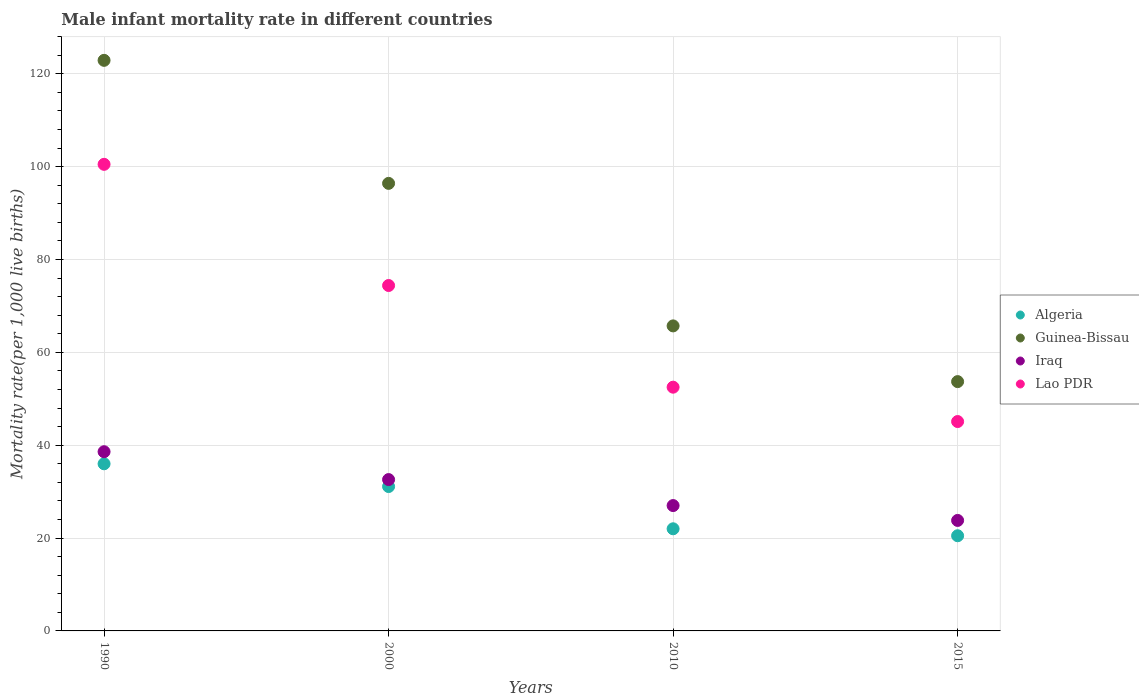Is the number of dotlines equal to the number of legend labels?
Your answer should be very brief. Yes. What is the male infant mortality rate in Guinea-Bissau in 2010?
Your answer should be compact. 65.7. Across all years, what is the maximum male infant mortality rate in Lao PDR?
Offer a very short reply. 100.5. Across all years, what is the minimum male infant mortality rate in Iraq?
Your answer should be very brief. 23.8. In which year was the male infant mortality rate in Algeria maximum?
Your response must be concise. 1990. In which year was the male infant mortality rate in Algeria minimum?
Give a very brief answer. 2015. What is the total male infant mortality rate in Lao PDR in the graph?
Provide a succinct answer. 272.5. What is the difference between the male infant mortality rate in Iraq in 1990 and that in 2010?
Your answer should be very brief. 11.6. What is the difference between the male infant mortality rate in Algeria in 2015 and the male infant mortality rate in Iraq in 1990?
Make the answer very short. -18.1. What is the average male infant mortality rate in Algeria per year?
Offer a terse response. 27.4. In the year 1990, what is the difference between the male infant mortality rate in Algeria and male infant mortality rate in Iraq?
Your answer should be very brief. -2.6. What is the ratio of the male infant mortality rate in Guinea-Bissau in 1990 to that in 2010?
Give a very brief answer. 1.87. Is the male infant mortality rate in Iraq in 1990 less than that in 2015?
Keep it short and to the point. No. What is the difference between the highest and the second highest male infant mortality rate in Lao PDR?
Provide a short and direct response. 26.1. In how many years, is the male infant mortality rate in Guinea-Bissau greater than the average male infant mortality rate in Guinea-Bissau taken over all years?
Offer a very short reply. 2. Is it the case that in every year, the sum of the male infant mortality rate in Guinea-Bissau and male infant mortality rate in Lao PDR  is greater than the sum of male infant mortality rate in Algeria and male infant mortality rate in Iraq?
Give a very brief answer. Yes. Does the male infant mortality rate in Guinea-Bissau monotonically increase over the years?
Keep it short and to the point. No. How many dotlines are there?
Offer a very short reply. 4. Are the values on the major ticks of Y-axis written in scientific E-notation?
Your answer should be very brief. No. Does the graph contain any zero values?
Your response must be concise. No. How many legend labels are there?
Ensure brevity in your answer.  4. How are the legend labels stacked?
Your answer should be very brief. Vertical. What is the title of the graph?
Your answer should be compact. Male infant mortality rate in different countries. What is the label or title of the X-axis?
Provide a short and direct response. Years. What is the label or title of the Y-axis?
Make the answer very short. Mortality rate(per 1,0 live births). What is the Mortality rate(per 1,000 live births) in Guinea-Bissau in 1990?
Offer a very short reply. 122.9. What is the Mortality rate(per 1,000 live births) in Iraq in 1990?
Your answer should be compact. 38.6. What is the Mortality rate(per 1,000 live births) in Lao PDR in 1990?
Your answer should be very brief. 100.5. What is the Mortality rate(per 1,000 live births) in Algeria in 2000?
Your response must be concise. 31.1. What is the Mortality rate(per 1,000 live births) in Guinea-Bissau in 2000?
Ensure brevity in your answer.  96.4. What is the Mortality rate(per 1,000 live births) of Iraq in 2000?
Provide a short and direct response. 32.6. What is the Mortality rate(per 1,000 live births) in Lao PDR in 2000?
Provide a short and direct response. 74.4. What is the Mortality rate(per 1,000 live births) of Guinea-Bissau in 2010?
Your answer should be very brief. 65.7. What is the Mortality rate(per 1,000 live births) in Lao PDR in 2010?
Offer a terse response. 52.5. What is the Mortality rate(per 1,000 live births) in Algeria in 2015?
Provide a short and direct response. 20.5. What is the Mortality rate(per 1,000 live births) in Guinea-Bissau in 2015?
Your answer should be compact. 53.7. What is the Mortality rate(per 1,000 live births) in Iraq in 2015?
Ensure brevity in your answer.  23.8. What is the Mortality rate(per 1,000 live births) in Lao PDR in 2015?
Provide a succinct answer. 45.1. Across all years, what is the maximum Mortality rate(per 1,000 live births) in Algeria?
Your answer should be compact. 36. Across all years, what is the maximum Mortality rate(per 1,000 live births) in Guinea-Bissau?
Keep it short and to the point. 122.9. Across all years, what is the maximum Mortality rate(per 1,000 live births) in Iraq?
Provide a short and direct response. 38.6. Across all years, what is the maximum Mortality rate(per 1,000 live births) in Lao PDR?
Your response must be concise. 100.5. Across all years, what is the minimum Mortality rate(per 1,000 live births) in Guinea-Bissau?
Offer a terse response. 53.7. Across all years, what is the minimum Mortality rate(per 1,000 live births) of Iraq?
Your answer should be very brief. 23.8. Across all years, what is the minimum Mortality rate(per 1,000 live births) of Lao PDR?
Ensure brevity in your answer.  45.1. What is the total Mortality rate(per 1,000 live births) of Algeria in the graph?
Your response must be concise. 109.6. What is the total Mortality rate(per 1,000 live births) of Guinea-Bissau in the graph?
Your response must be concise. 338.7. What is the total Mortality rate(per 1,000 live births) in Iraq in the graph?
Your response must be concise. 122. What is the total Mortality rate(per 1,000 live births) in Lao PDR in the graph?
Make the answer very short. 272.5. What is the difference between the Mortality rate(per 1,000 live births) in Algeria in 1990 and that in 2000?
Your response must be concise. 4.9. What is the difference between the Mortality rate(per 1,000 live births) of Iraq in 1990 and that in 2000?
Offer a terse response. 6. What is the difference between the Mortality rate(per 1,000 live births) of Lao PDR in 1990 and that in 2000?
Provide a succinct answer. 26.1. What is the difference between the Mortality rate(per 1,000 live births) in Guinea-Bissau in 1990 and that in 2010?
Keep it short and to the point. 57.2. What is the difference between the Mortality rate(per 1,000 live births) of Iraq in 1990 and that in 2010?
Keep it short and to the point. 11.6. What is the difference between the Mortality rate(per 1,000 live births) in Algeria in 1990 and that in 2015?
Provide a short and direct response. 15.5. What is the difference between the Mortality rate(per 1,000 live births) of Guinea-Bissau in 1990 and that in 2015?
Offer a very short reply. 69.2. What is the difference between the Mortality rate(per 1,000 live births) of Iraq in 1990 and that in 2015?
Keep it short and to the point. 14.8. What is the difference between the Mortality rate(per 1,000 live births) of Lao PDR in 1990 and that in 2015?
Offer a very short reply. 55.4. What is the difference between the Mortality rate(per 1,000 live births) of Algeria in 2000 and that in 2010?
Keep it short and to the point. 9.1. What is the difference between the Mortality rate(per 1,000 live births) in Guinea-Bissau in 2000 and that in 2010?
Your response must be concise. 30.7. What is the difference between the Mortality rate(per 1,000 live births) of Lao PDR in 2000 and that in 2010?
Provide a succinct answer. 21.9. What is the difference between the Mortality rate(per 1,000 live births) in Guinea-Bissau in 2000 and that in 2015?
Offer a very short reply. 42.7. What is the difference between the Mortality rate(per 1,000 live births) of Lao PDR in 2000 and that in 2015?
Your answer should be compact. 29.3. What is the difference between the Mortality rate(per 1,000 live births) of Iraq in 2010 and that in 2015?
Your answer should be very brief. 3.2. What is the difference between the Mortality rate(per 1,000 live births) of Algeria in 1990 and the Mortality rate(per 1,000 live births) of Guinea-Bissau in 2000?
Offer a very short reply. -60.4. What is the difference between the Mortality rate(per 1,000 live births) in Algeria in 1990 and the Mortality rate(per 1,000 live births) in Lao PDR in 2000?
Make the answer very short. -38.4. What is the difference between the Mortality rate(per 1,000 live births) of Guinea-Bissau in 1990 and the Mortality rate(per 1,000 live births) of Iraq in 2000?
Offer a terse response. 90.3. What is the difference between the Mortality rate(per 1,000 live births) in Guinea-Bissau in 1990 and the Mortality rate(per 1,000 live births) in Lao PDR in 2000?
Ensure brevity in your answer.  48.5. What is the difference between the Mortality rate(per 1,000 live births) of Iraq in 1990 and the Mortality rate(per 1,000 live births) of Lao PDR in 2000?
Provide a succinct answer. -35.8. What is the difference between the Mortality rate(per 1,000 live births) of Algeria in 1990 and the Mortality rate(per 1,000 live births) of Guinea-Bissau in 2010?
Your response must be concise. -29.7. What is the difference between the Mortality rate(per 1,000 live births) of Algeria in 1990 and the Mortality rate(per 1,000 live births) of Lao PDR in 2010?
Make the answer very short. -16.5. What is the difference between the Mortality rate(per 1,000 live births) of Guinea-Bissau in 1990 and the Mortality rate(per 1,000 live births) of Iraq in 2010?
Ensure brevity in your answer.  95.9. What is the difference between the Mortality rate(per 1,000 live births) of Guinea-Bissau in 1990 and the Mortality rate(per 1,000 live births) of Lao PDR in 2010?
Make the answer very short. 70.4. What is the difference between the Mortality rate(per 1,000 live births) of Iraq in 1990 and the Mortality rate(per 1,000 live births) of Lao PDR in 2010?
Ensure brevity in your answer.  -13.9. What is the difference between the Mortality rate(per 1,000 live births) in Algeria in 1990 and the Mortality rate(per 1,000 live births) in Guinea-Bissau in 2015?
Your response must be concise. -17.7. What is the difference between the Mortality rate(per 1,000 live births) in Algeria in 1990 and the Mortality rate(per 1,000 live births) in Iraq in 2015?
Provide a short and direct response. 12.2. What is the difference between the Mortality rate(per 1,000 live births) in Guinea-Bissau in 1990 and the Mortality rate(per 1,000 live births) in Iraq in 2015?
Keep it short and to the point. 99.1. What is the difference between the Mortality rate(per 1,000 live births) of Guinea-Bissau in 1990 and the Mortality rate(per 1,000 live births) of Lao PDR in 2015?
Give a very brief answer. 77.8. What is the difference between the Mortality rate(per 1,000 live births) of Algeria in 2000 and the Mortality rate(per 1,000 live births) of Guinea-Bissau in 2010?
Ensure brevity in your answer.  -34.6. What is the difference between the Mortality rate(per 1,000 live births) of Algeria in 2000 and the Mortality rate(per 1,000 live births) of Iraq in 2010?
Offer a terse response. 4.1. What is the difference between the Mortality rate(per 1,000 live births) of Algeria in 2000 and the Mortality rate(per 1,000 live births) of Lao PDR in 2010?
Give a very brief answer. -21.4. What is the difference between the Mortality rate(per 1,000 live births) of Guinea-Bissau in 2000 and the Mortality rate(per 1,000 live births) of Iraq in 2010?
Your response must be concise. 69.4. What is the difference between the Mortality rate(per 1,000 live births) in Guinea-Bissau in 2000 and the Mortality rate(per 1,000 live births) in Lao PDR in 2010?
Provide a short and direct response. 43.9. What is the difference between the Mortality rate(per 1,000 live births) of Iraq in 2000 and the Mortality rate(per 1,000 live births) of Lao PDR in 2010?
Your answer should be very brief. -19.9. What is the difference between the Mortality rate(per 1,000 live births) of Algeria in 2000 and the Mortality rate(per 1,000 live births) of Guinea-Bissau in 2015?
Your response must be concise. -22.6. What is the difference between the Mortality rate(per 1,000 live births) in Algeria in 2000 and the Mortality rate(per 1,000 live births) in Iraq in 2015?
Offer a very short reply. 7.3. What is the difference between the Mortality rate(per 1,000 live births) in Guinea-Bissau in 2000 and the Mortality rate(per 1,000 live births) in Iraq in 2015?
Ensure brevity in your answer.  72.6. What is the difference between the Mortality rate(per 1,000 live births) of Guinea-Bissau in 2000 and the Mortality rate(per 1,000 live births) of Lao PDR in 2015?
Make the answer very short. 51.3. What is the difference between the Mortality rate(per 1,000 live births) of Algeria in 2010 and the Mortality rate(per 1,000 live births) of Guinea-Bissau in 2015?
Offer a terse response. -31.7. What is the difference between the Mortality rate(per 1,000 live births) in Algeria in 2010 and the Mortality rate(per 1,000 live births) in Lao PDR in 2015?
Provide a short and direct response. -23.1. What is the difference between the Mortality rate(per 1,000 live births) of Guinea-Bissau in 2010 and the Mortality rate(per 1,000 live births) of Iraq in 2015?
Provide a succinct answer. 41.9. What is the difference between the Mortality rate(per 1,000 live births) of Guinea-Bissau in 2010 and the Mortality rate(per 1,000 live births) of Lao PDR in 2015?
Make the answer very short. 20.6. What is the difference between the Mortality rate(per 1,000 live births) in Iraq in 2010 and the Mortality rate(per 1,000 live births) in Lao PDR in 2015?
Your response must be concise. -18.1. What is the average Mortality rate(per 1,000 live births) of Algeria per year?
Your response must be concise. 27.4. What is the average Mortality rate(per 1,000 live births) of Guinea-Bissau per year?
Your answer should be very brief. 84.67. What is the average Mortality rate(per 1,000 live births) of Iraq per year?
Provide a succinct answer. 30.5. What is the average Mortality rate(per 1,000 live births) of Lao PDR per year?
Ensure brevity in your answer.  68.12. In the year 1990, what is the difference between the Mortality rate(per 1,000 live births) of Algeria and Mortality rate(per 1,000 live births) of Guinea-Bissau?
Make the answer very short. -86.9. In the year 1990, what is the difference between the Mortality rate(per 1,000 live births) of Algeria and Mortality rate(per 1,000 live births) of Iraq?
Provide a short and direct response. -2.6. In the year 1990, what is the difference between the Mortality rate(per 1,000 live births) of Algeria and Mortality rate(per 1,000 live births) of Lao PDR?
Provide a succinct answer. -64.5. In the year 1990, what is the difference between the Mortality rate(per 1,000 live births) in Guinea-Bissau and Mortality rate(per 1,000 live births) in Iraq?
Keep it short and to the point. 84.3. In the year 1990, what is the difference between the Mortality rate(per 1,000 live births) of Guinea-Bissau and Mortality rate(per 1,000 live births) of Lao PDR?
Keep it short and to the point. 22.4. In the year 1990, what is the difference between the Mortality rate(per 1,000 live births) of Iraq and Mortality rate(per 1,000 live births) of Lao PDR?
Keep it short and to the point. -61.9. In the year 2000, what is the difference between the Mortality rate(per 1,000 live births) in Algeria and Mortality rate(per 1,000 live births) in Guinea-Bissau?
Ensure brevity in your answer.  -65.3. In the year 2000, what is the difference between the Mortality rate(per 1,000 live births) of Algeria and Mortality rate(per 1,000 live births) of Lao PDR?
Offer a terse response. -43.3. In the year 2000, what is the difference between the Mortality rate(per 1,000 live births) in Guinea-Bissau and Mortality rate(per 1,000 live births) in Iraq?
Your answer should be very brief. 63.8. In the year 2000, what is the difference between the Mortality rate(per 1,000 live births) in Iraq and Mortality rate(per 1,000 live births) in Lao PDR?
Your answer should be compact. -41.8. In the year 2010, what is the difference between the Mortality rate(per 1,000 live births) in Algeria and Mortality rate(per 1,000 live births) in Guinea-Bissau?
Your answer should be compact. -43.7. In the year 2010, what is the difference between the Mortality rate(per 1,000 live births) in Algeria and Mortality rate(per 1,000 live births) in Iraq?
Make the answer very short. -5. In the year 2010, what is the difference between the Mortality rate(per 1,000 live births) in Algeria and Mortality rate(per 1,000 live births) in Lao PDR?
Your response must be concise. -30.5. In the year 2010, what is the difference between the Mortality rate(per 1,000 live births) in Guinea-Bissau and Mortality rate(per 1,000 live births) in Iraq?
Ensure brevity in your answer.  38.7. In the year 2010, what is the difference between the Mortality rate(per 1,000 live births) in Iraq and Mortality rate(per 1,000 live births) in Lao PDR?
Your answer should be very brief. -25.5. In the year 2015, what is the difference between the Mortality rate(per 1,000 live births) in Algeria and Mortality rate(per 1,000 live births) in Guinea-Bissau?
Your answer should be compact. -33.2. In the year 2015, what is the difference between the Mortality rate(per 1,000 live births) of Algeria and Mortality rate(per 1,000 live births) of Lao PDR?
Your response must be concise. -24.6. In the year 2015, what is the difference between the Mortality rate(per 1,000 live births) in Guinea-Bissau and Mortality rate(per 1,000 live births) in Iraq?
Offer a terse response. 29.9. In the year 2015, what is the difference between the Mortality rate(per 1,000 live births) of Iraq and Mortality rate(per 1,000 live births) of Lao PDR?
Provide a short and direct response. -21.3. What is the ratio of the Mortality rate(per 1,000 live births) in Algeria in 1990 to that in 2000?
Your answer should be compact. 1.16. What is the ratio of the Mortality rate(per 1,000 live births) of Guinea-Bissau in 1990 to that in 2000?
Offer a very short reply. 1.27. What is the ratio of the Mortality rate(per 1,000 live births) in Iraq in 1990 to that in 2000?
Offer a very short reply. 1.18. What is the ratio of the Mortality rate(per 1,000 live births) of Lao PDR in 1990 to that in 2000?
Give a very brief answer. 1.35. What is the ratio of the Mortality rate(per 1,000 live births) in Algeria in 1990 to that in 2010?
Your answer should be very brief. 1.64. What is the ratio of the Mortality rate(per 1,000 live births) in Guinea-Bissau in 1990 to that in 2010?
Your answer should be compact. 1.87. What is the ratio of the Mortality rate(per 1,000 live births) of Iraq in 1990 to that in 2010?
Give a very brief answer. 1.43. What is the ratio of the Mortality rate(per 1,000 live births) of Lao PDR in 1990 to that in 2010?
Provide a succinct answer. 1.91. What is the ratio of the Mortality rate(per 1,000 live births) in Algeria in 1990 to that in 2015?
Make the answer very short. 1.76. What is the ratio of the Mortality rate(per 1,000 live births) of Guinea-Bissau in 1990 to that in 2015?
Your answer should be very brief. 2.29. What is the ratio of the Mortality rate(per 1,000 live births) in Iraq in 1990 to that in 2015?
Give a very brief answer. 1.62. What is the ratio of the Mortality rate(per 1,000 live births) of Lao PDR in 1990 to that in 2015?
Provide a succinct answer. 2.23. What is the ratio of the Mortality rate(per 1,000 live births) in Algeria in 2000 to that in 2010?
Ensure brevity in your answer.  1.41. What is the ratio of the Mortality rate(per 1,000 live births) in Guinea-Bissau in 2000 to that in 2010?
Make the answer very short. 1.47. What is the ratio of the Mortality rate(per 1,000 live births) in Iraq in 2000 to that in 2010?
Make the answer very short. 1.21. What is the ratio of the Mortality rate(per 1,000 live births) in Lao PDR in 2000 to that in 2010?
Your answer should be very brief. 1.42. What is the ratio of the Mortality rate(per 1,000 live births) in Algeria in 2000 to that in 2015?
Your response must be concise. 1.52. What is the ratio of the Mortality rate(per 1,000 live births) in Guinea-Bissau in 2000 to that in 2015?
Ensure brevity in your answer.  1.8. What is the ratio of the Mortality rate(per 1,000 live births) of Iraq in 2000 to that in 2015?
Make the answer very short. 1.37. What is the ratio of the Mortality rate(per 1,000 live births) of Lao PDR in 2000 to that in 2015?
Provide a succinct answer. 1.65. What is the ratio of the Mortality rate(per 1,000 live births) in Algeria in 2010 to that in 2015?
Your response must be concise. 1.07. What is the ratio of the Mortality rate(per 1,000 live births) of Guinea-Bissau in 2010 to that in 2015?
Your response must be concise. 1.22. What is the ratio of the Mortality rate(per 1,000 live births) in Iraq in 2010 to that in 2015?
Your answer should be compact. 1.13. What is the ratio of the Mortality rate(per 1,000 live births) in Lao PDR in 2010 to that in 2015?
Your response must be concise. 1.16. What is the difference between the highest and the second highest Mortality rate(per 1,000 live births) in Guinea-Bissau?
Provide a short and direct response. 26.5. What is the difference between the highest and the second highest Mortality rate(per 1,000 live births) in Iraq?
Offer a terse response. 6. What is the difference between the highest and the second highest Mortality rate(per 1,000 live births) in Lao PDR?
Give a very brief answer. 26.1. What is the difference between the highest and the lowest Mortality rate(per 1,000 live births) of Guinea-Bissau?
Ensure brevity in your answer.  69.2. What is the difference between the highest and the lowest Mortality rate(per 1,000 live births) of Iraq?
Ensure brevity in your answer.  14.8. What is the difference between the highest and the lowest Mortality rate(per 1,000 live births) in Lao PDR?
Your response must be concise. 55.4. 